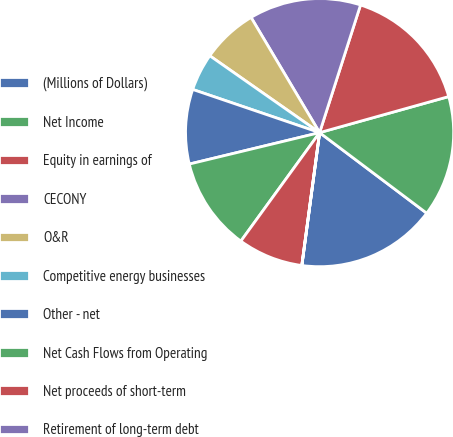Convert chart to OTSL. <chart><loc_0><loc_0><loc_500><loc_500><pie_chart><fcel>(Millions of Dollars)<fcel>Net Income<fcel>Equity in earnings of<fcel>CECONY<fcel>O&R<fcel>Competitive energy businesses<fcel>Other - net<fcel>Net Cash Flows from Operating<fcel>Net proceeds of short-term<fcel>Retirement of long-term debt<nl><fcel>16.85%<fcel>14.6%<fcel>15.73%<fcel>13.48%<fcel>6.74%<fcel>4.5%<fcel>8.99%<fcel>11.24%<fcel>7.87%<fcel>0.01%<nl></chart> 